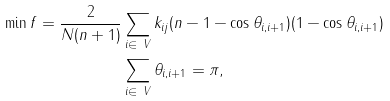Convert formula to latex. <formula><loc_0><loc_0><loc_500><loc_500>\min f = \frac { 2 } { N ( n + 1 ) } & \sum _ { i \in \ V } k _ { i j } ( n - 1 - \cos \theta _ { i , i + 1 } ) ( 1 - \cos \theta _ { i , i + 1 } ) \\ & \sum _ { i \in \ V } \theta _ { i , i + 1 } = \pi ,</formula> 